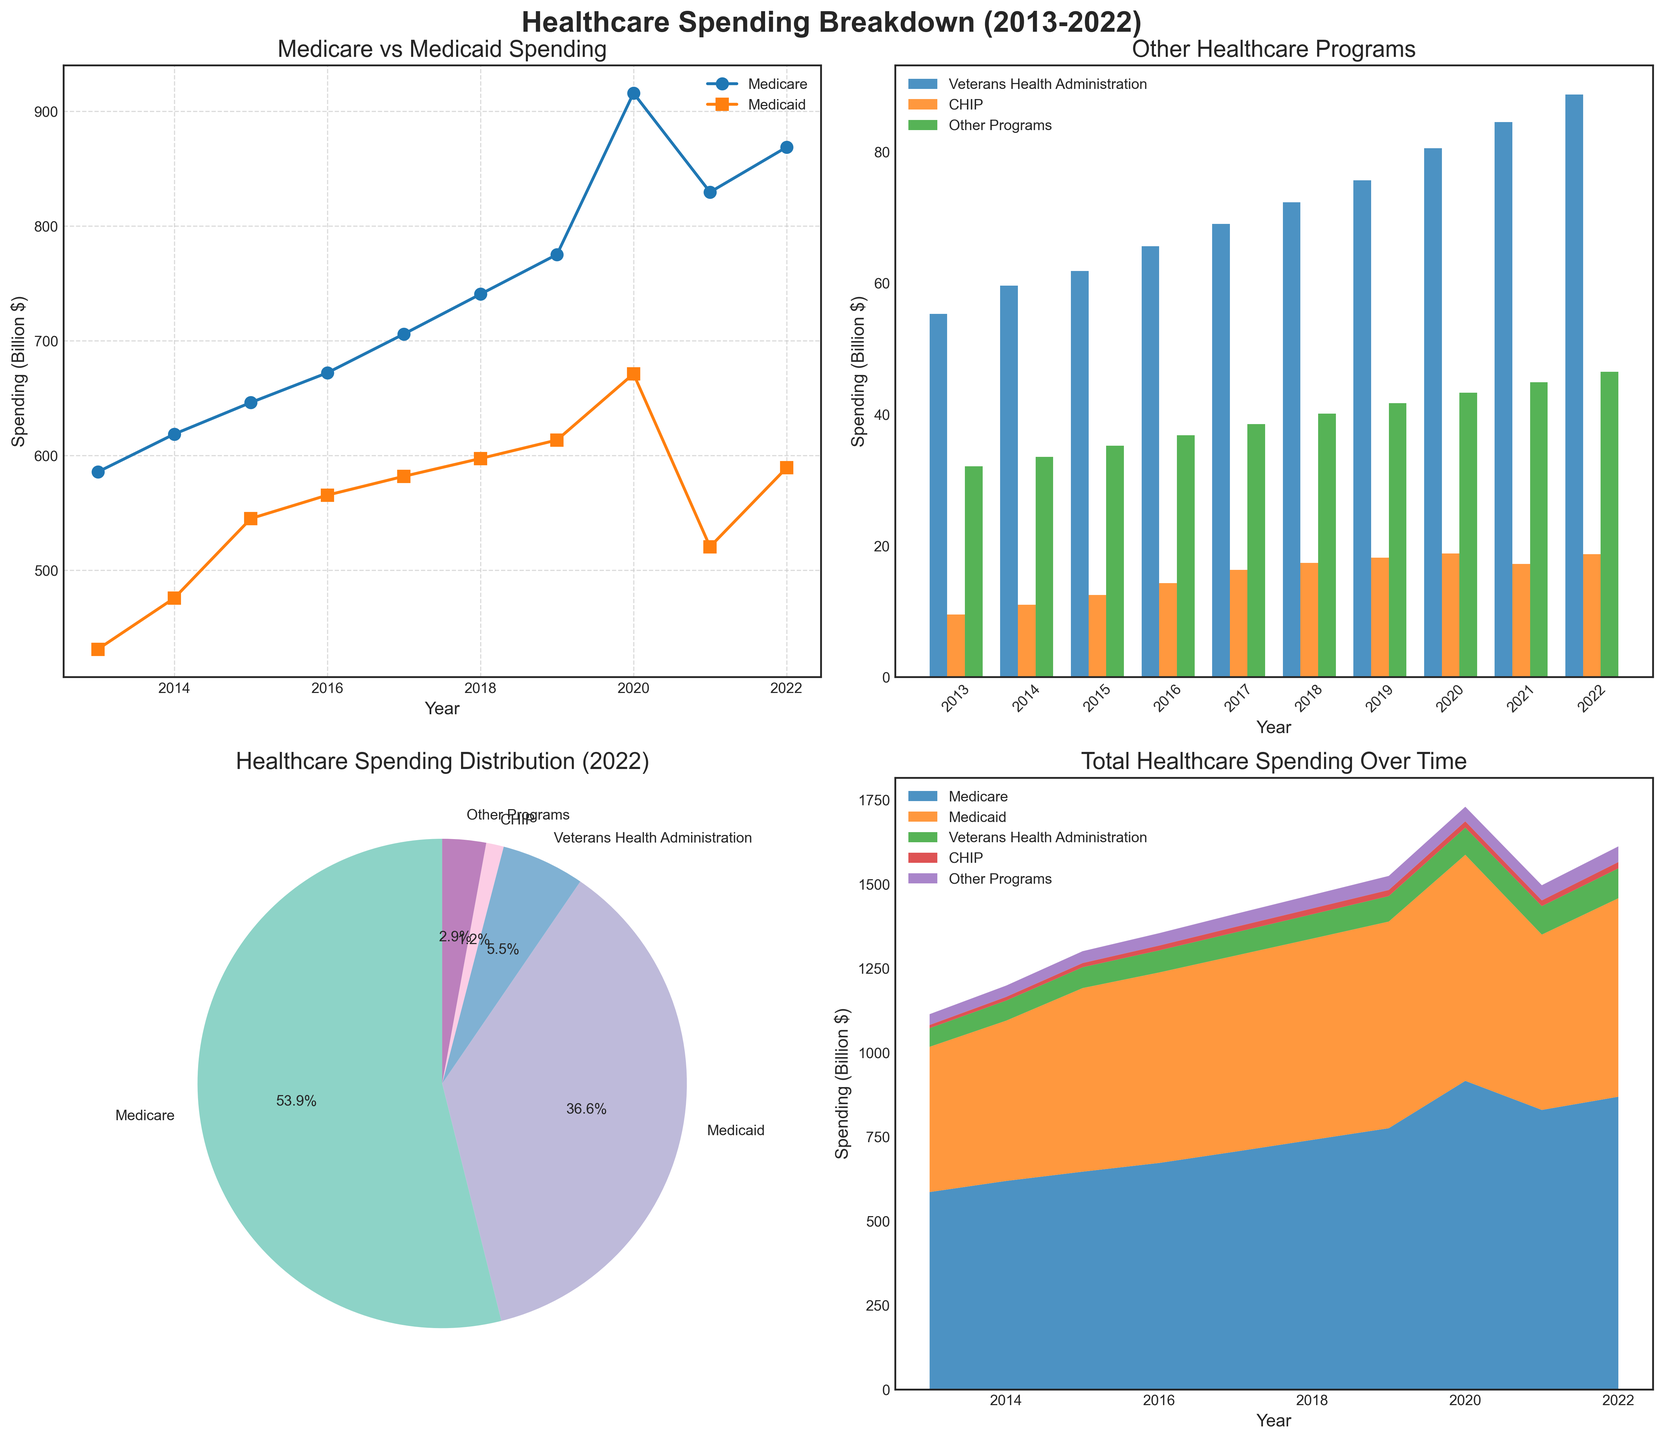What is the title of the overall figure? The title of the overall figure is shown at the top of the plot and usually summarizes what the plots are about. Here it reads 'Healthcare Spending Breakdown (2013-2022)'.
Answer: Healthcare Spending Breakdown (2013-2022) Which programs are displayed in the line plot? The line plot in the top-left corner shows two lines with labels indicating the programs. The plot is titled 'Medicare vs Medicaid Spending' and the legend confirms that the two programs are 'Medicare' and 'Medicaid'.
Answer: Medicare and Medicaid What is the spending on Medicare in 2019? In the top-left line plot labeled 'Medicare vs Medicaid Spending', the 2019 value for Medicare can be found by tracing the marker for 2019 along the 'Medicare' line. It is labeled with a marker at approximately 775.2 billion dollars.
Answer: 775.2 billion dollars How does the spending on Veterans Health Administration change from 2021 to 2022? To answer this, look at the bar plot in the top-right corner and compare the bars for the 'Veterans Health Administration' program in 2021 and 2022. The height of the 2021 bar is approximately 84.5 billion dollars, and the 2022 bar is about 88.7 billion dollars.
Answer: It increased by 4.2 billion dollars What percentage of total healthcare spending in 2022 is attributed to CHIP? The pie chart in the bottom-left corner shows the percentage distribution of different programs for 2022. To find the value specific to CHIP, look at the slice labeled 'CHIP' and its corresponding percentage. CHIP is shown as making up 2.6% of 2022 healthcare spending.
Answer: 2.6% Which healthcare program had the largest absolute increase in spending from 2013 to 2022? First, check each program's spending in 2013 and 2022 using the line plots and bar graphs. Calculate the absolute differences: Medicare (868.7 - 585.7 = 283), Medicaid (589.3 - 431.2 = 158.1), Veterans Health Administration (88.7 - 55.3 = 33.4), CHIP (18.7 - 9.5 = 9.2), Other Programs (46.5 - 32.1 = 14.4). Medicare has the largest increase.
Answer: Medicare Which year had the highest total healthcare spending? To determine the year with the highest total spending, look at the stacked area chart in the bottom-right. The total spending in each year is represented by the overall height of the stacked areas. The highest point indicates 2020.
Answer: 2020 From the line plot, which year did Medicaid spending surpass 500 billion dollars? On the top-left line plot, trace the Medicaid (square marker) line to find the year when it first exceeds 500 billion. This occurs in 2015.
Answer: 2015 Which two programs combined take up over 75% of the healthcare spending distribution in 2022? Refer to the pie chart, where each slice represents a program's percentage. Identify two programs where their summed percentages exceed 75%. Medicare (45.2%) and Medicaid (30.7%) together sum to 75.9%.
Answer: Medicare and Medicaid What trend can be observed in the spending on CHIP from 2013 to 2022? Examine the CHIP bars in the bar plot over the years. Observe whether the heights are increasing, decreasing, or remaining constant. The heights consistently increase, indicating an upward trend from 9.5 billion dollars in 2013 to 18.7 billion dollars in 2022.
Answer: Upward trend 